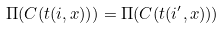Convert formula to latex. <formula><loc_0><loc_0><loc_500><loc_500>\Pi ( C ( t ( i , x ) ) ) = \Pi ( C ( t ( i ^ { \prime } , x ) ) )</formula> 